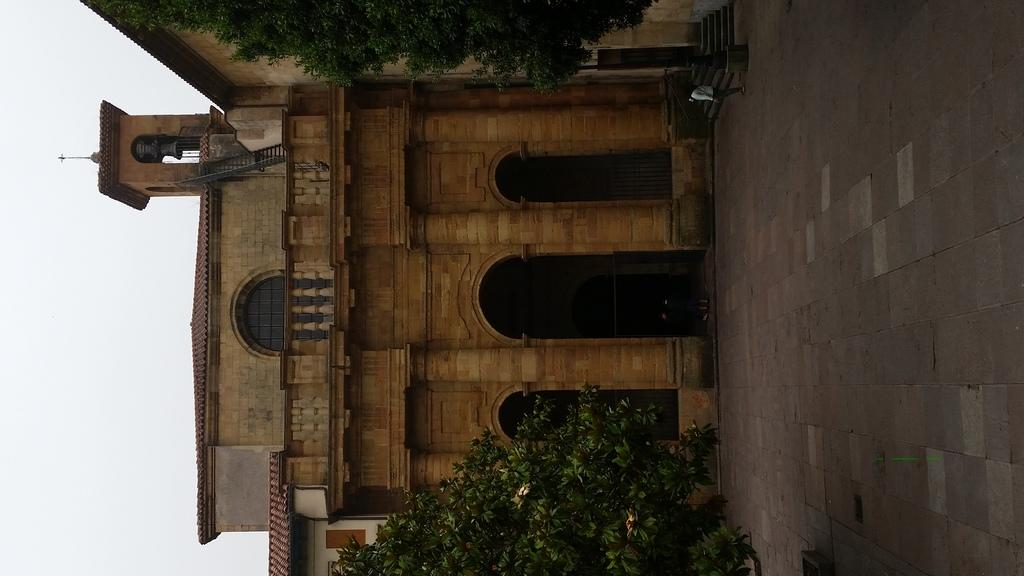What type of structure is present in the image? There is a building in the image. What other natural elements can be seen in the image? There are trees in the image. How many people are visible in the image? Two persons are standing on the floor in the image. What part of the sky is visible in the image? The sky is visible on the left side of the image. What type of goldfish can be seen swimming in the sky on the left side of the image? There are no goldfish present in the image; the sky is visible on the left side of the image. 